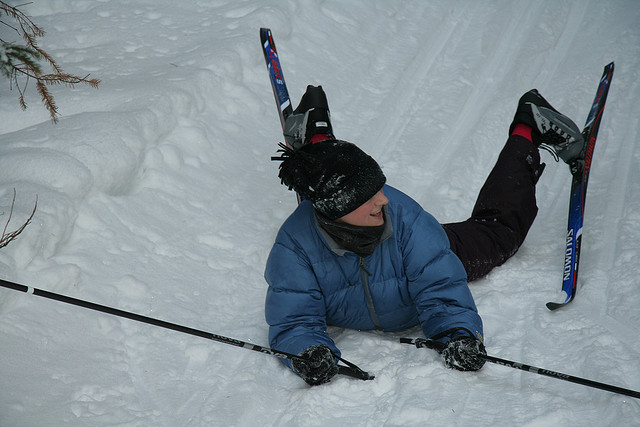Identify and read out the text in this image. NOWOIVZ 